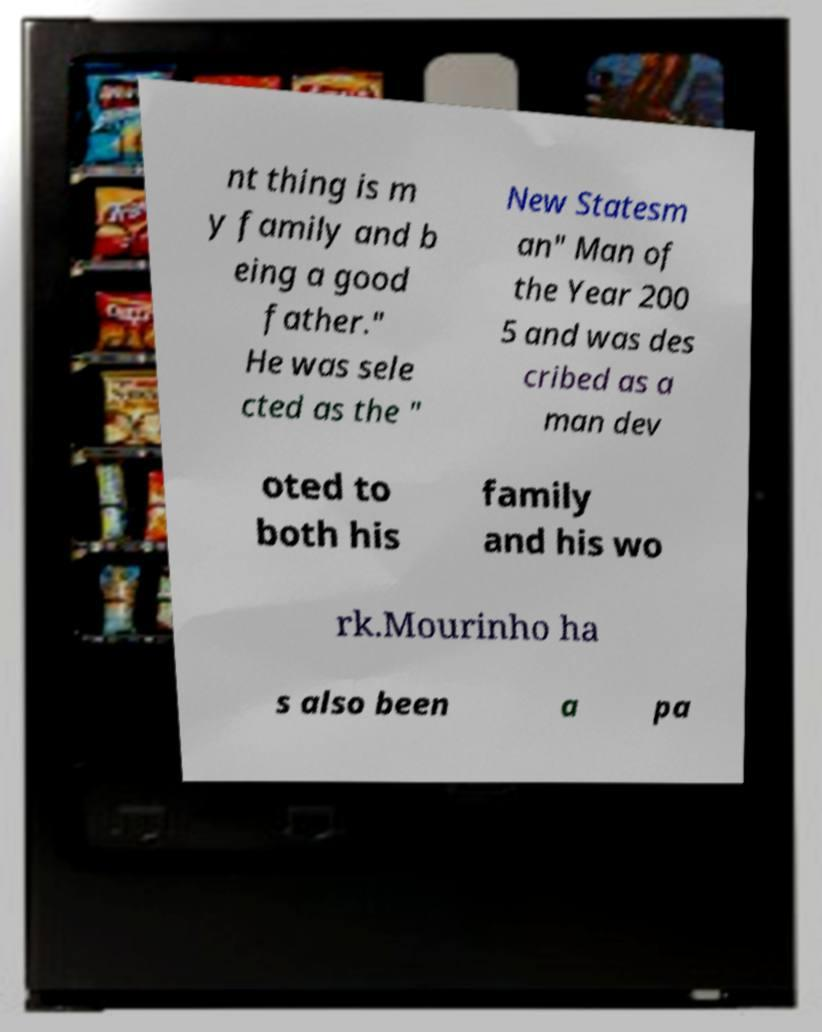What does the text on the paper in front of the TV relate to? The text on the paper appears to be part of an article or a statement about a person discussing his dedication to family and his recognition in the year 2005. It likely references a public figure, focusing on both personal values and professional achievements. 